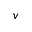<formula> <loc_0><loc_0><loc_500><loc_500>v</formula> 